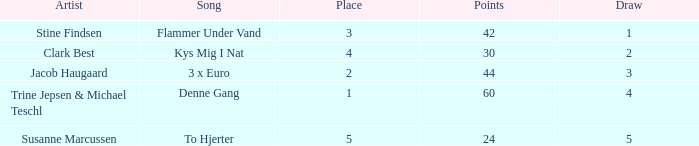What is the Draw that has Points larger than 44 and a Place larger than 1? None. 